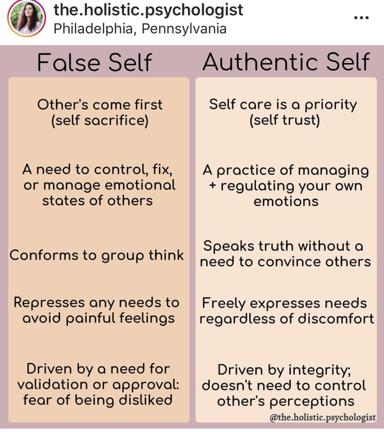Can you explain how someone might identify if they are living as their false self or authentic self based on the image? According to the image, individuals can assess their tendencies between the false and authentic selves by examining their behaviors and motivations. If you frequently prioritize others at your expense, feel the need to control or influence how others feel, conform easily to group norms, suppress your needs to avoid conflict, or seek external approval extensively, you might be operating from a false self. The authentic self, on the other hand, emerges as you begin practicing self-care, managing your emotions independently, expressing your truth and needs freely, and acting from a place of personal integrity without seeking external validation. 